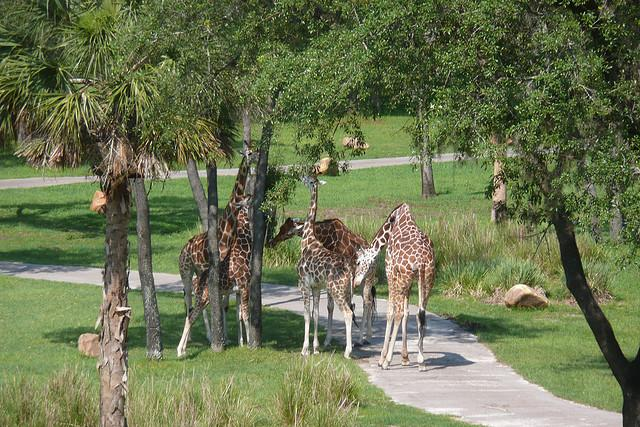What are the giraffes playing around?

Choices:
A) babies
B) cars
C) coyotes
D) trees trees 